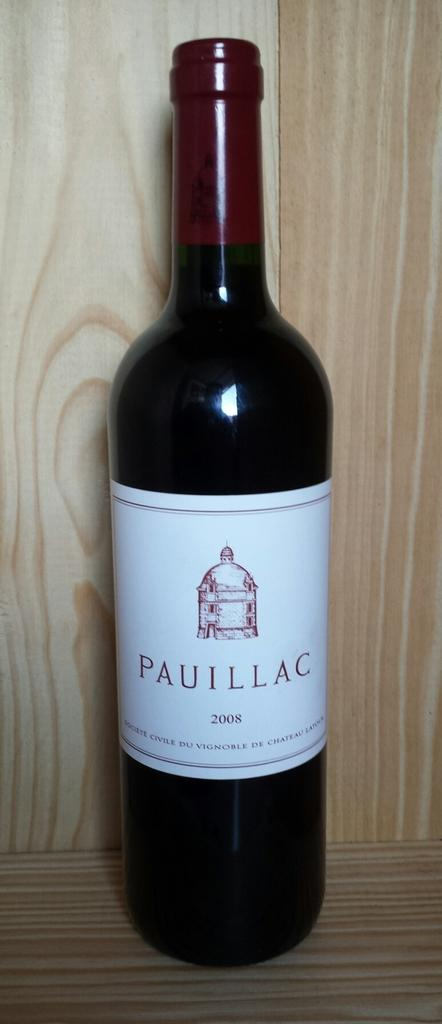<image>
Give a short and clear explanation of the subsequent image. A 2008 bottle of Pauillac red wine against a wooden backdrop 